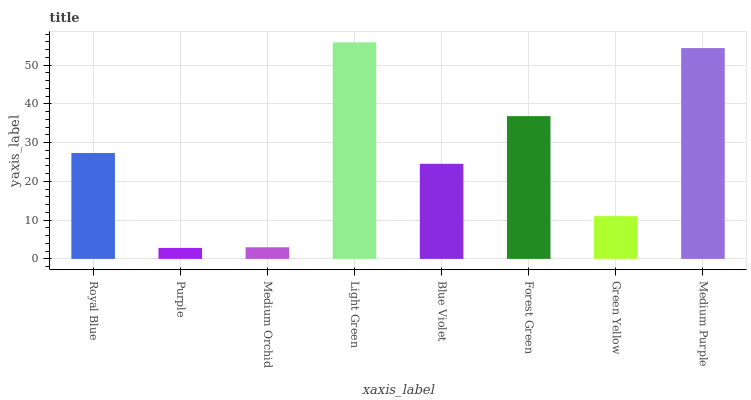Is Purple the minimum?
Answer yes or no. Yes. Is Light Green the maximum?
Answer yes or no. Yes. Is Medium Orchid the minimum?
Answer yes or no. No. Is Medium Orchid the maximum?
Answer yes or no. No. Is Medium Orchid greater than Purple?
Answer yes or no. Yes. Is Purple less than Medium Orchid?
Answer yes or no. Yes. Is Purple greater than Medium Orchid?
Answer yes or no. No. Is Medium Orchid less than Purple?
Answer yes or no. No. Is Royal Blue the high median?
Answer yes or no. Yes. Is Blue Violet the low median?
Answer yes or no. Yes. Is Green Yellow the high median?
Answer yes or no. No. Is Medium Purple the low median?
Answer yes or no. No. 